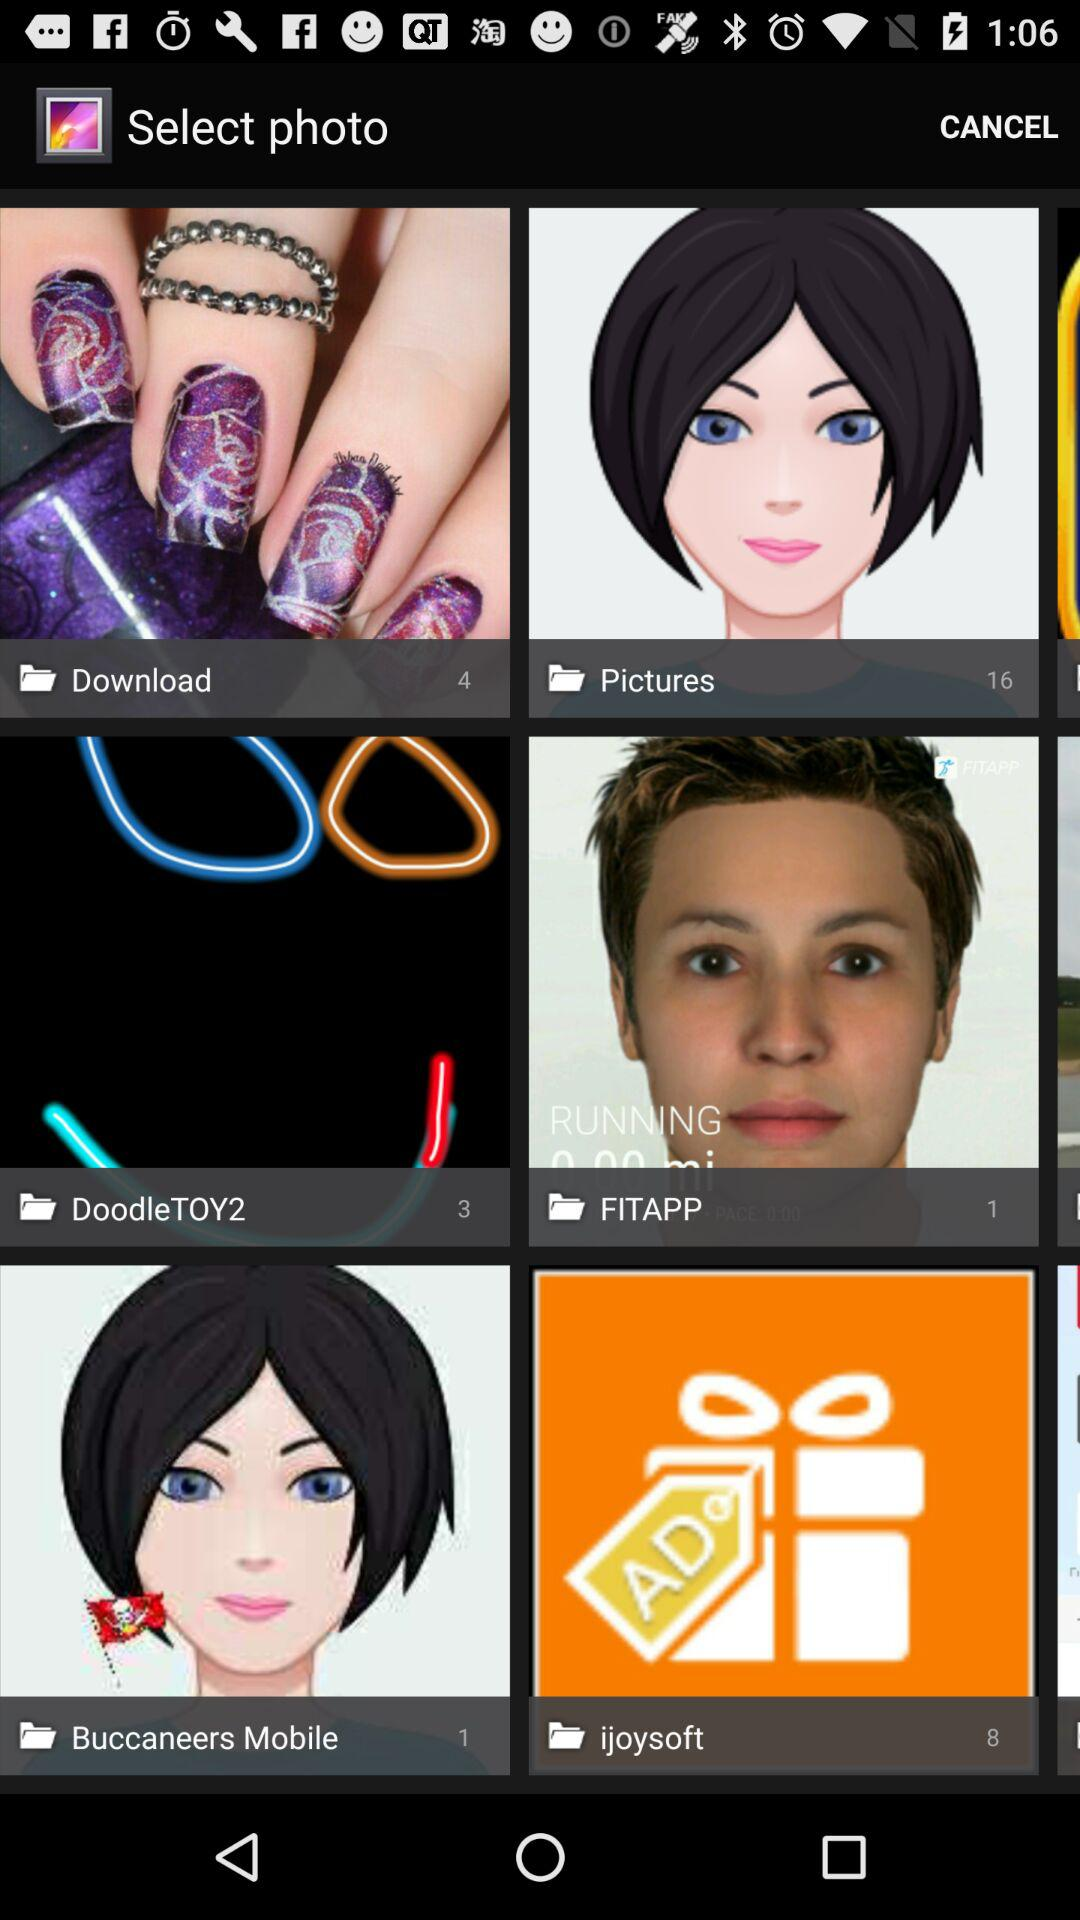How many more pictures than downloads are there?
Answer the question using a single word or phrase. 12 